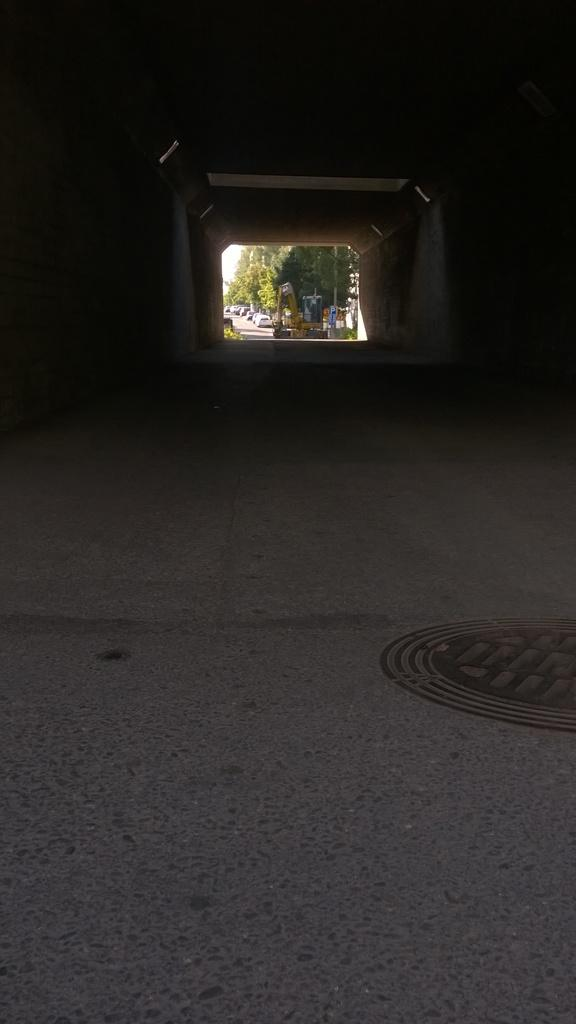What mode of transportation is visible at the top side of the image? There is a subway at the top side of the image. What can be seen in the background of the image? There are cars and trees in the background of the image. What type of juice is being served in the subway? There is no juice present in the image; it only shows a subway and the background with cars and trees. 